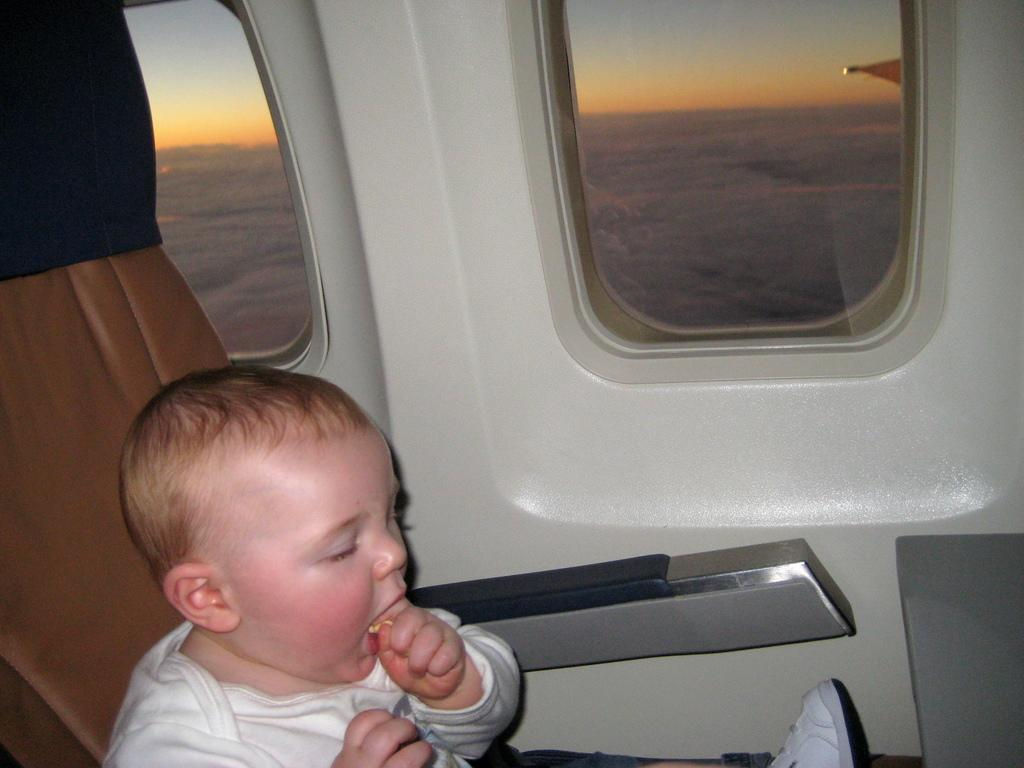What is the main subject of the image? The main subject of the image appears to be an aeroplane. Where is the small baby located in the image? The small baby is on the left side of the image. What is the baby sitting on? The baby is on a chair. What can be seen in the center of the image? There are windows in the center of the image. What type of cable is being used by the baby to play with in the image? There is no cable present in the image, and the baby is not shown playing with anything. 